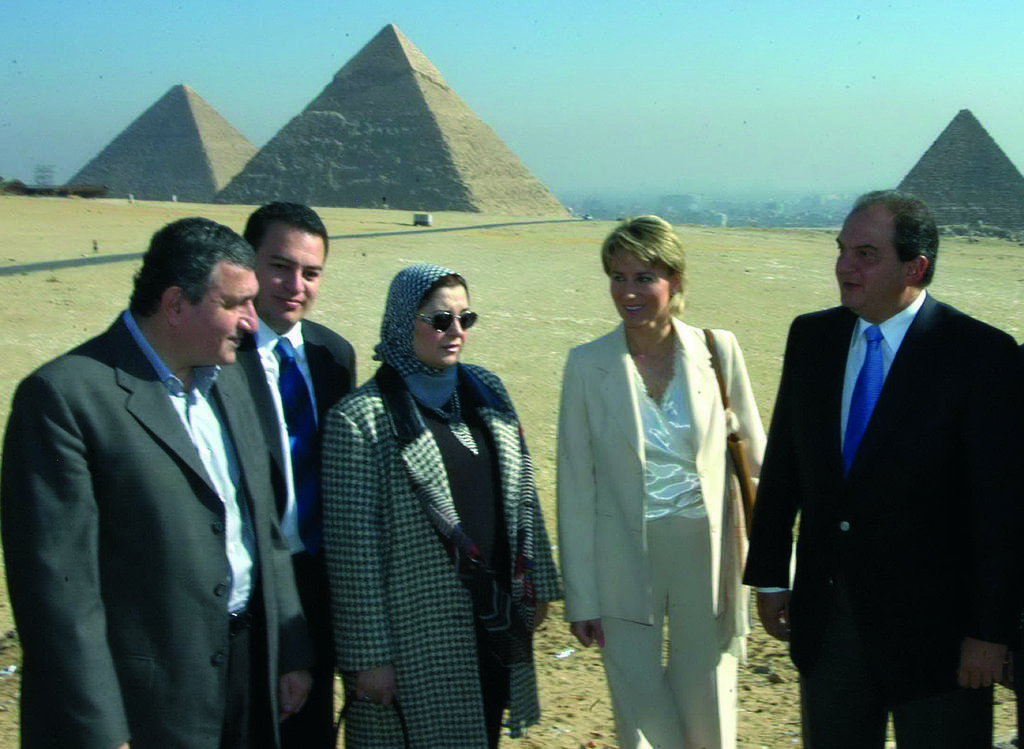Describe this image in one or two sentences. In this image we can see many people standing. One lady is wearing goggles and a scarf on the head. And another lady is holding a bag. In the back there are pyramids. And there is sky. 